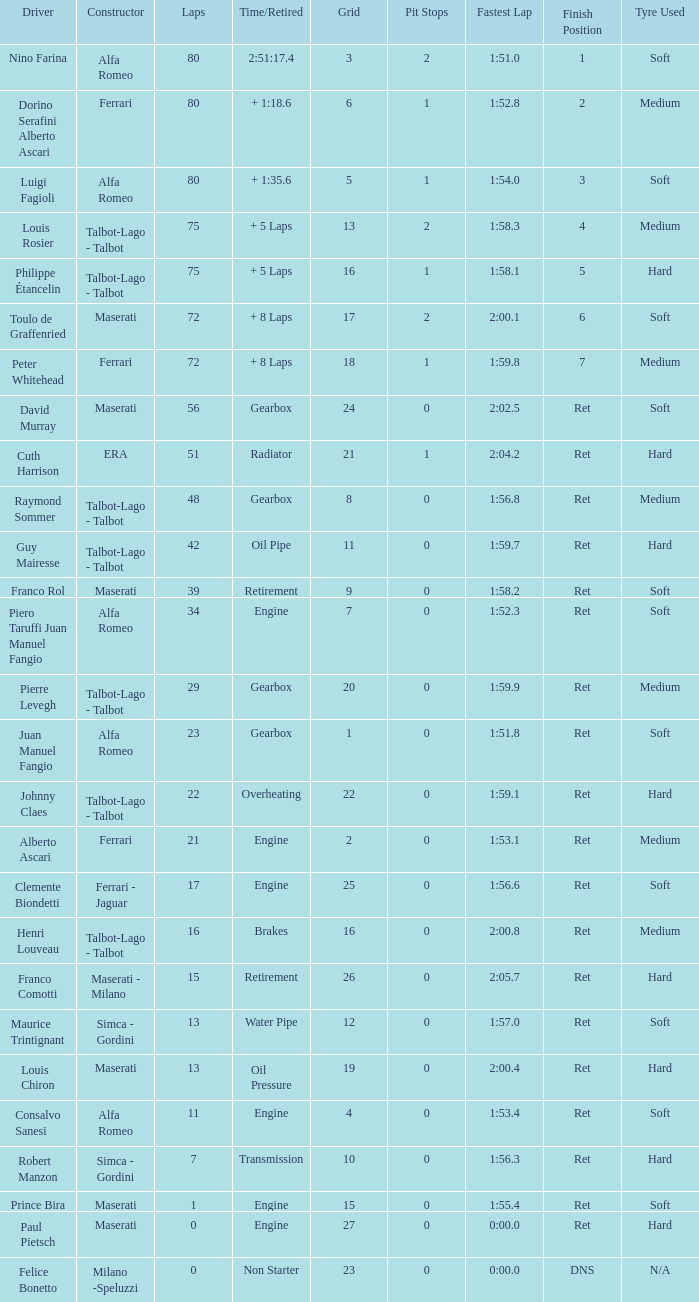When grid is less than 7, laps are greater than 17, and time/retired is + 1:35.6, who is the constructor? Alfa Romeo. 